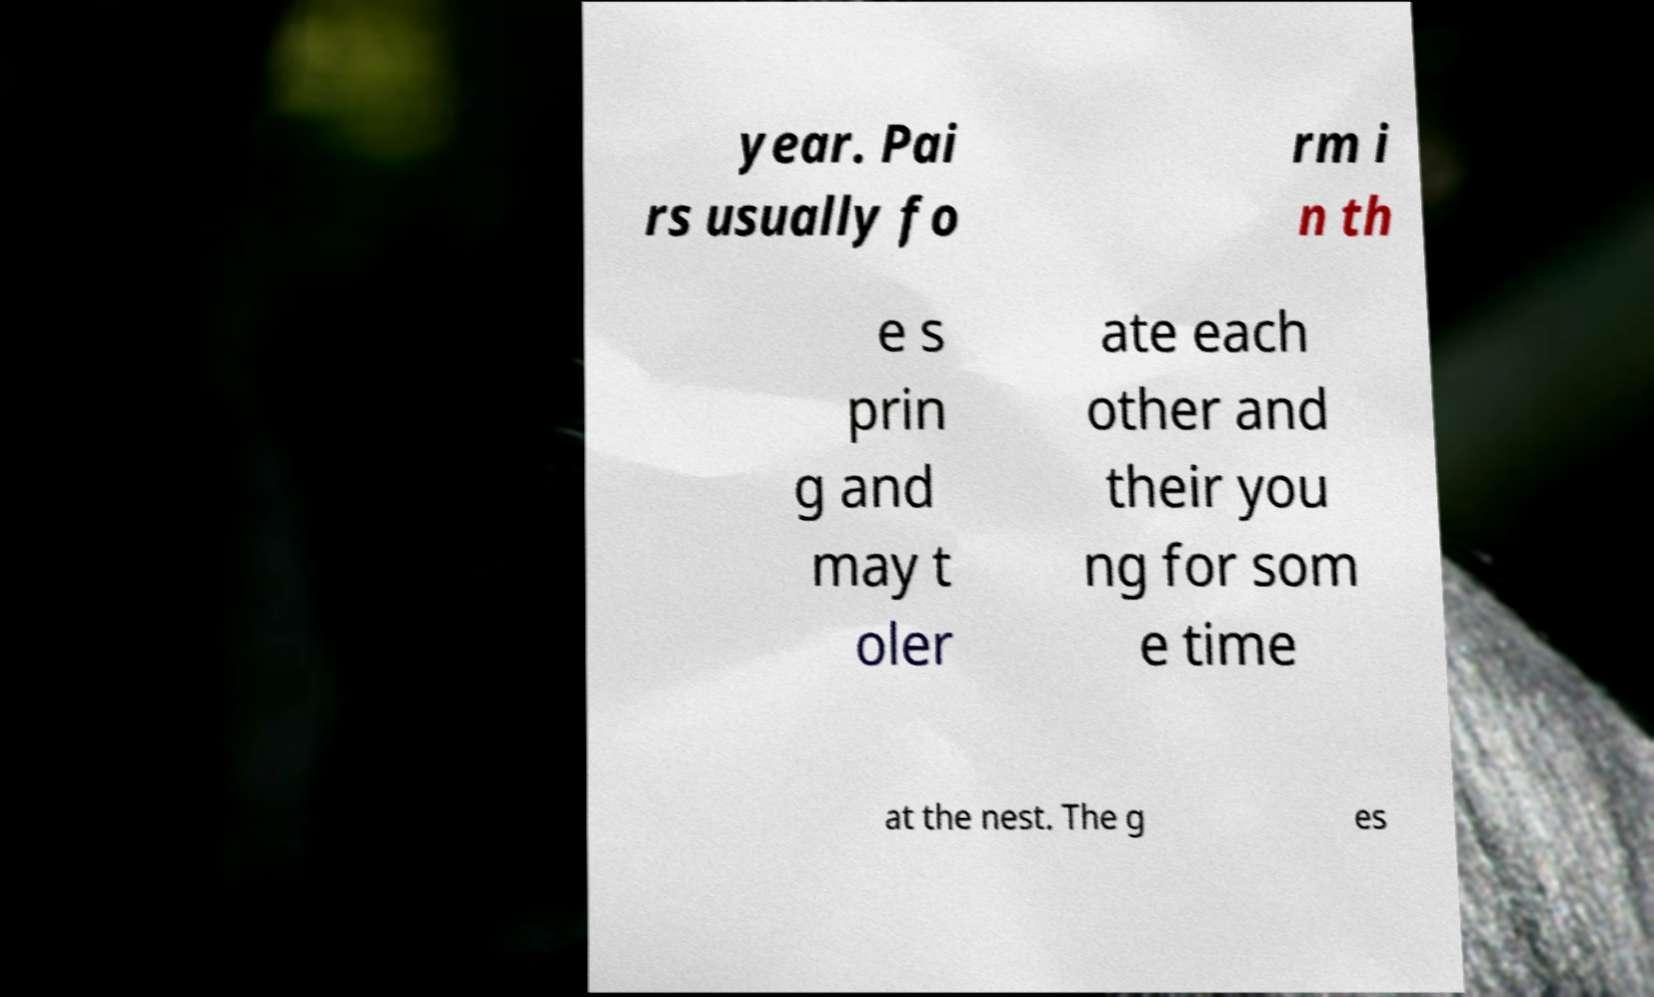Could you extract and type out the text from this image? year. Pai rs usually fo rm i n th e s prin g and may t oler ate each other and their you ng for som e time at the nest. The g es 